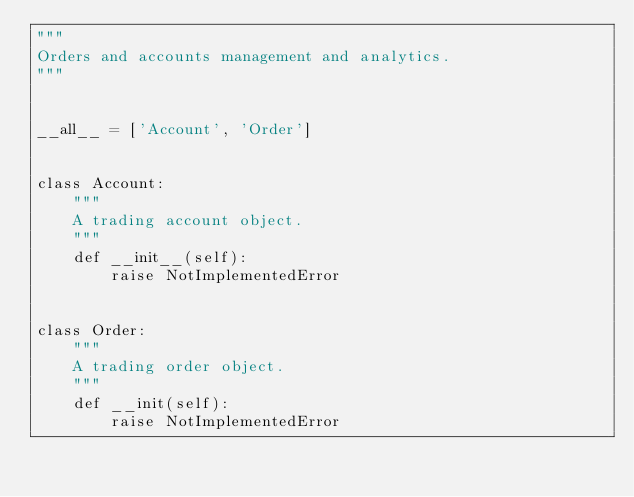Convert code to text. <code><loc_0><loc_0><loc_500><loc_500><_Python_>"""
Orders and accounts management and analytics.
"""


__all__ = ['Account', 'Order']


class Account:
    """
    A trading account object.
    """
    def __init__(self):
        raise NotImplementedError


class Order:
    """
    A trading order object.
    """
    def __init(self):
        raise NotImplementedError
</code> 